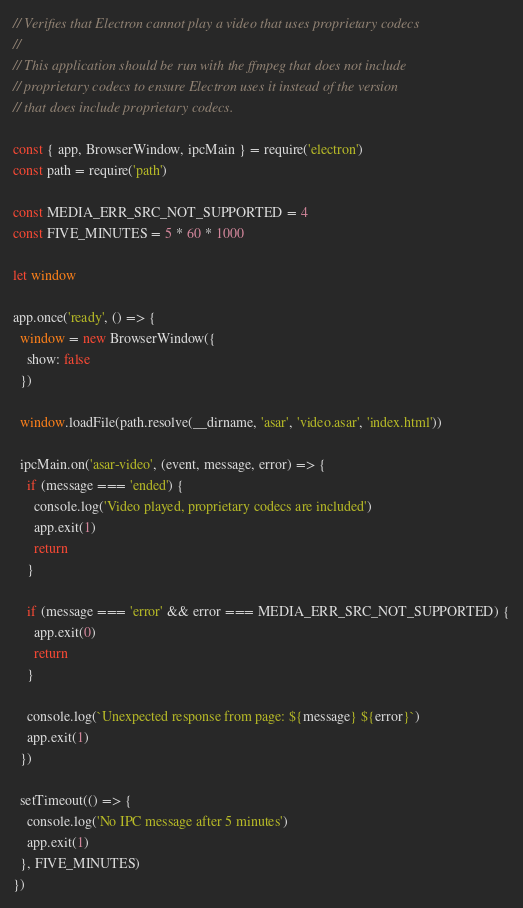<code> <loc_0><loc_0><loc_500><loc_500><_JavaScript_>// Verifies that Electron cannot play a video that uses proprietary codecs
//
// This application should be run with the ffmpeg that does not include
// proprietary codecs to ensure Electron uses it instead of the version
// that does include proprietary codecs.

const { app, BrowserWindow, ipcMain } = require('electron')
const path = require('path')

const MEDIA_ERR_SRC_NOT_SUPPORTED = 4
const FIVE_MINUTES = 5 * 60 * 1000

let window

app.once('ready', () => {
  window = new BrowserWindow({
    show: false
  })

  window.loadFile(path.resolve(__dirname, 'asar', 'video.asar', 'index.html'))

  ipcMain.on('asar-video', (event, message, error) => {
    if (message === 'ended') {
      console.log('Video played, proprietary codecs are included')
      app.exit(1)
      return
    }

    if (message === 'error' && error === MEDIA_ERR_SRC_NOT_SUPPORTED) {
      app.exit(0)
      return
    }

    console.log(`Unexpected response from page: ${message} ${error}`)
    app.exit(1)
  })

  setTimeout(() => {
    console.log('No IPC message after 5 minutes')
    app.exit(1)
  }, FIVE_MINUTES)
})
</code> 